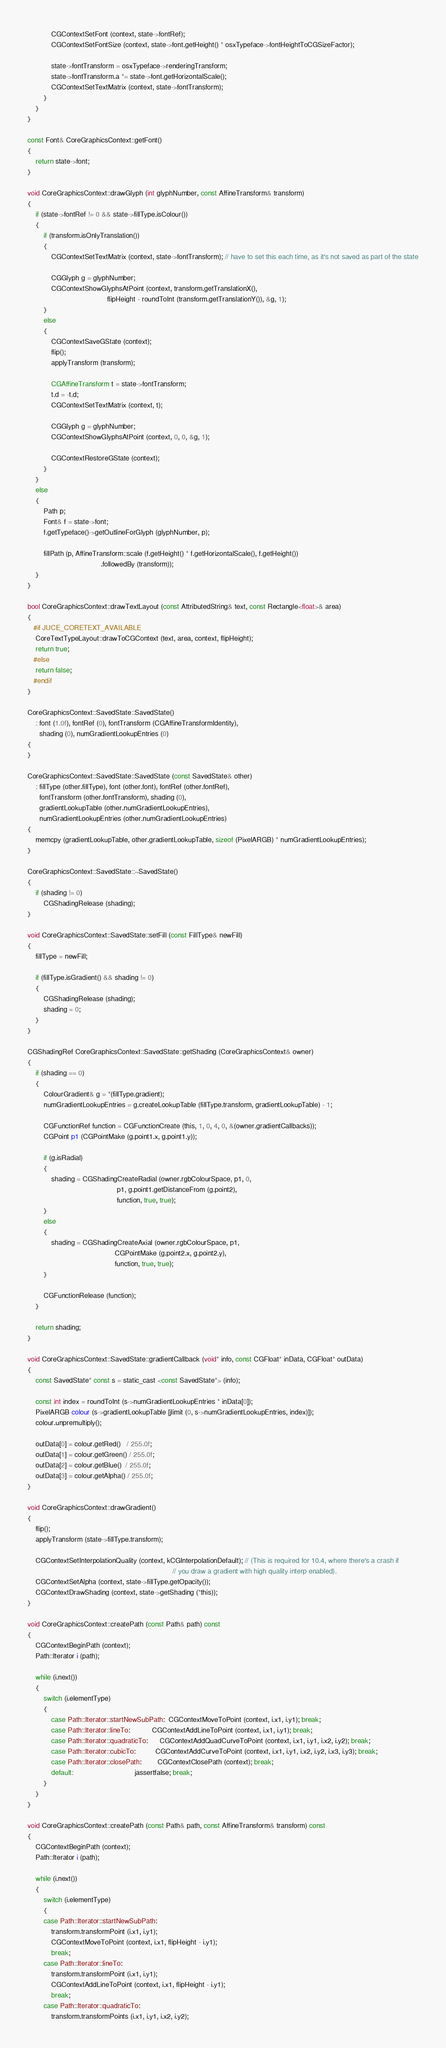Convert code to text. <code><loc_0><loc_0><loc_500><loc_500><_ObjectiveC_>            CGContextSetFont (context, state->fontRef);
            CGContextSetFontSize (context, state->font.getHeight() * osxTypeface->fontHeightToCGSizeFactor);

            state->fontTransform = osxTypeface->renderingTransform;
            state->fontTransform.a *= state->font.getHorizontalScale();
            CGContextSetTextMatrix (context, state->fontTransform);
        }
    }
}

const Font& CoreGraphicsContext::getFont()
{
    return state->font;
}

void CoreGraphicsContext::drawGlyph (int glyphNumber, const AffineTransform& transform)
{
    if (state->fontRef != 0 && state->fillType.isColour())
    {
        if (transform.isOnlyTranslation())
        {
            CGContextSetTextMatrix (context, state->fontTransform); // have to set this each time, as it's not saved as part of the state

            CGGlyph g = glyphNumber;
            CGContextShowGlyphsAtPoint (context, transform.getTranslationX(),
                                        flipHeight - roundToInt (transform.getTranslationY()), &g, 1);
        }
        else
        {
            CGContextSaveGState (context);
            flip();
            applyTransform (transform);

            CGAffineTransform t = state->fontTransform;
            t.d = -t.d;
            CGContextSetTextMatrix (context, t);

            CGGlyph g = glyphNumber;
            CGContextShowGlyphsAtPoint (context, 0, 0, &g, 1);

            CGContextRestoreGState (context);
        }
    }
    else
    {
        Path p;
        Font& f = state->font;
        f.getTypeface()->getOutlineForGlyph (glyphNumber, p);

        fillPath (p, AffineTransform::scale (f.getHeight() * f.getHorizontalScale(), f.getHeight())
                                     .followedBy (transform));
    }
}

bool CoreGraphicsContext::drawTextLayout (const AttributedString& text, const Rectangle<float>& area)
{
   #if JUCE_CORETEXT_AVAILABLE
    CoreTextTypeLayout::drawToCGContext (text, area, context, flipHeight);
    return true;
   #else
    return false;
   #endif
}

CoreGraphicsContext::SavedState::SavedState()
    : font (1.0f), fontRef (0), fontTransform (CGAffineTransformIdentity),
      shading (0), numGradientLookupEntries (0)
{
}

CoreGraphicsContext::SavedState::SavedState (const SavedState& other)
    : fillType (other.fillType), font (other.font), fontRef (other.fontRef),
      fontTransform (other.fontTransform), shading (0),
      gradientLookupTable (other.numGradientLookupEntries),
      numGradientLookupEntries (other.numGradientLookupEntries)
{
    memcpy (gradientLookupTable, other.gradientLookupTable, sizeof (PixelARGB) * numGradientLookupEntries);
}

CoreGraphicsContext::SavedState::~SavedState()
{
    if (shading != 0)
        CGShadingRelease (shading);
}

void CoreGraphicsContext::SavedState::setFill (const FillType& newFill)
{
    fillType = newFill;

    if (fillType.isGradient() && shading != 0)
    {
        CGShadingRelease (shading);
        shading = 0;
    }
}

CGShadingRef CoreGraphicsContext::SavedState::getShading (CoreGraphicsContext& owner)
{
    if (shading == 0)
    {
        ColourGradient& g = *(fillType.gradient);
        numGradientLookupEntries = g.createLookupTable (fillType.transform, gradientLookupTable) - 1;

        CGFunctionRef function = CGFunctionCreate (this, 1, 0, 4, 0, &(owner.gradientCallbacks));
        CGPoint p1 (CGPointMake (g.point1.x, g.point1.y));

        if (g.isRadial)
        {
            shading = CGShadingCreateRadial (owner.rgbColourSpace, p1, 0,
                                             p1, g.point1.getDistanceFrom (g.point2),
                                             function, true, true);
        }
        else
        {
            shading = CGShadingCreateAxial (owner.rgbColourSpace, p1,
                                            CGPointMake (g.point2.x, g.point2.y),
                                            function, true, true);
        }

        CGFunctionRelease (function);
    }

    return shading;
}

void CoreGraphicsContext::SavedState::gradientCallback (void* info, const CGFloat* inData, CGFloat* outData)
{
    const SavedState* const s = static_cast <const SavedState*> (info);

    const int index = roundToInt (s->numGradientLookupEntries * inData[0]);
    PixelARGB colour (s->gradientLookupTable [jlimit (0, s->numGradientLookupEntries, index)]);
    colour.unpremultiply();

    outData[0] = colour.getRed()   / 255.0f;
    outData[1] = colour.getGreen() / 255.0f;
    outData[2] = colour.getBlue()  / 255.0f;
    outData[3] = colour.getAlpha() / 255.0f;
}

void CoreGraphicsContext::drawGradient()
{
    flip();
    applyTransform (state->fillType.transform);

    CGContextSetInterpolationQuality (context, kCGInterpolationDefault); // (This is required for 10.4, where there's a crash if
                                                                         // you draw a gradient with high quality interp enabled).
    CGContextSetAlpha (context, state->fillType.getOpacity());
    CGContextDrawShading (context, state->getShading (*this));
}

void CoreGraphicsContext::createPath (const Path& path) const
{
    CGContextBeginPath (context);
    Path::Iterator i (path);

    while (i.next())
    {
        switch (i.elementType)
        {
            case Path::Iterator::startNewSubPath:  CGContextMoveToPoint (context, i.x1, i.y1); break;
            case Path::Iterator::lineTo:           CGContextAddLineToPoint (context, i.x1, i.y1); break;
            case Path::Iterator::quadraticTo:      CGContextAddQuadCurveToPoint (context, i.x1, i.y1, i.x2, i.y2); break;
            case Path::Iterator::cubicTo:          CGContextAddCurveToPoint (context, i.x1, i.y1, i.x2, i.y2, i.x3, i.y3); break;
            case Path::Iterator::closePath:        CGContextClosePath (context); break;
            default:                               jassertfalse; break;
        }
    }
}

void CoreGraphicsContext::createPath (const Path& path, const AffineTransform& transform) const
{
    CGContextBeginPath (context);
    Path::Iterator i (path);

    while (i.next())
    {
        switch (i.elementType)
        {
        case Path::Iterator::startNewSubPath:
            transform.transformPoint (i.x1, i.y1);
            CGContextMoveToPoint (context, i.x1, flipHeight - i.y1);
            break;
        case Path::Iterator::lineTo:
            transform.transformPoint (i.x1, i.y1);
            CGContextAddLineToPoint (context, i.x1, flipHeight - i.y1);
            break;
        case Path::Iterator::quadraticTo:
            transform.transformPoints (i.x1, i.y1, i.x2, i.y2);</code> 